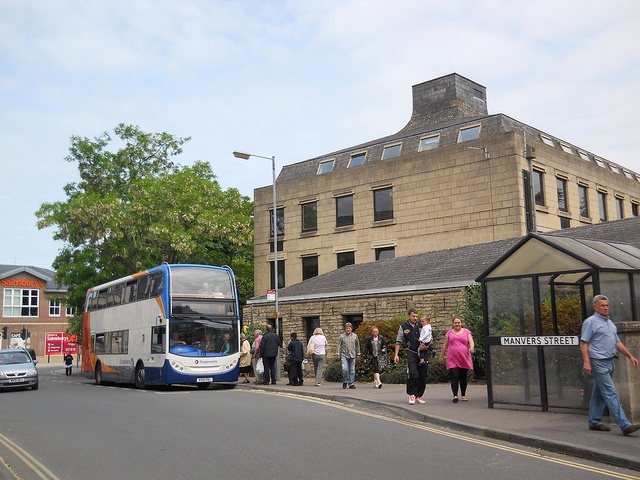Describe the objects in this image and their specific colors. I can see bus in lightgray, darkgray, black, and gray tones, people in lightgray, gray, black, and darkgray tones, people in lavender, black, gray, brown, and darkgray tones, people in lightgray, black, violet, purple, and brown tones, and car in lightgray, darkgray, gray, and black tones in this image. 